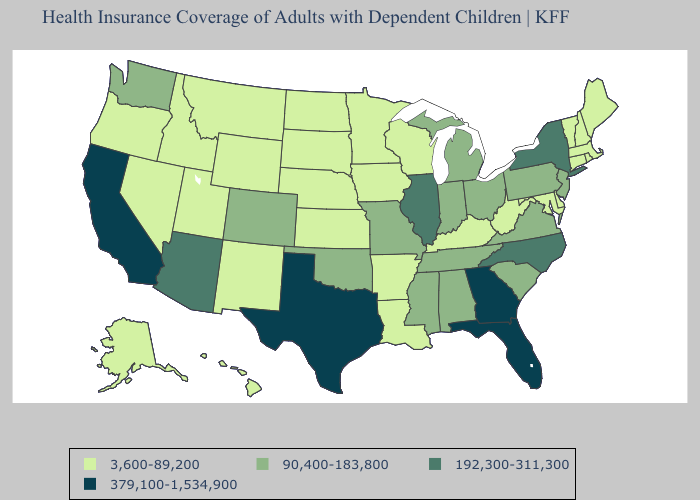Among the states that border West Virginia , does Kentucky have the highest value?
Short answer required. No. Does Hawaii have a lower value than Louisiana?
Keep it brief. No. What is the value of Idaho?
Write a very short answer. 3,600-89,200. Does South Carolina have the highest value in the USA?
Be succinct. No. What is the value of New Hampshire?
Short answer required. 3,600-89,200. Name the states that have a value in the range 379,100-1,534,900?
Be succinct. California, Florida, Georgia, Texas. Which states hav the highest value in the West?
Answer briefly. California. Does the map have missing data?
Short answer required. No. Among the states that border Mississippi , does Arkansas have the highest value?
Quick response, please. No. Among the states that border Missouri , which have the lowest value?
Short answer required. Arkansas, Iowa, Kansas, Kentucky, Nebraska. Which states hav the highest value in the MidWest?
Answer briefly. Illinois. What is the value of New York?
Write a very short answer. 192,300-311,300. Does North Carolina have the same value as Mississippi?
Keep it brief. No. What is the value of Kansas?
Keep it brief. 3,600-89,200. 